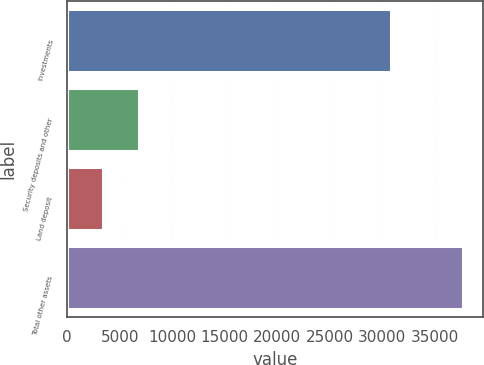<chart> <loc_0><loc_0><loc_500><loc_500><bar_chart><fcel>Investments<fcel>Security deposits and other<fcel>Land deposit<fcel>Total other assets<nl><fcel>30840<fcel>6812.3<fcel>3378<fcel>37721<nl></chart> 